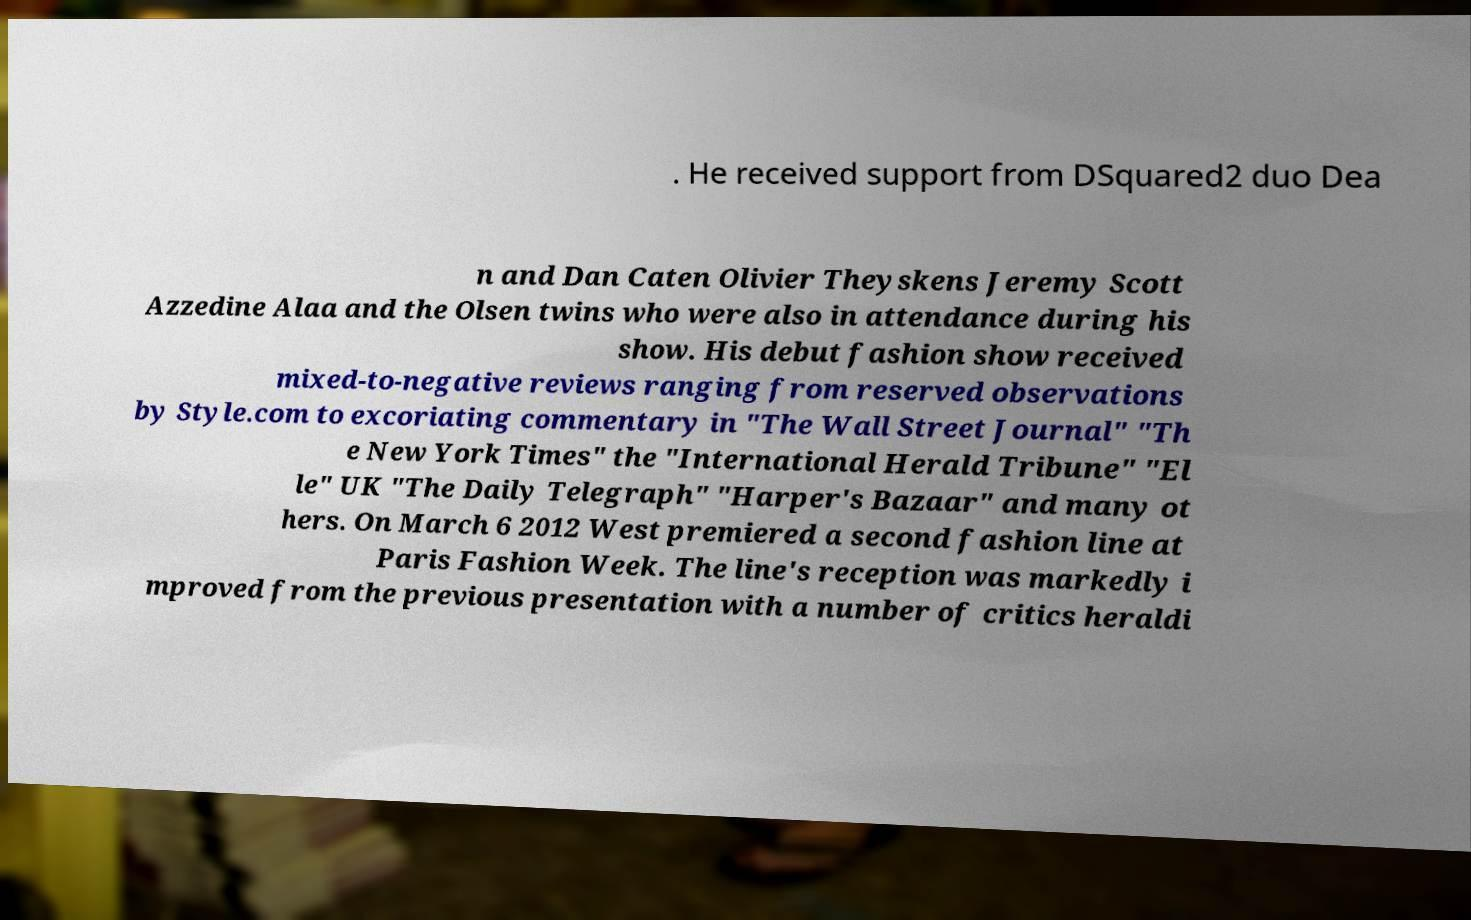For documentation purposes, I need the text within this image transcribed. Could you provide that? . He received support from DSquared2 duo Dea n and Dan Caten Olivier Theyskens Jeremy Scott Azzedine Alaa and the Olsen twins who were also in attendance during his show. His debut fashion show received mixed-to-negative reviews ranging from reserved observations by Style.com to excoriating commentary in "The Wall Street Journal" "Th e New York Times" the "International Herald Tribune" "El le" UK "The Daily Telegraph" "Harper's Bazaar" and many ot hers. On March 6 2012 West premiered a second fashion line at Paris Fashion Week. The line's reception was markedly i mproved from the previous presentation with a number of critics heraldi 